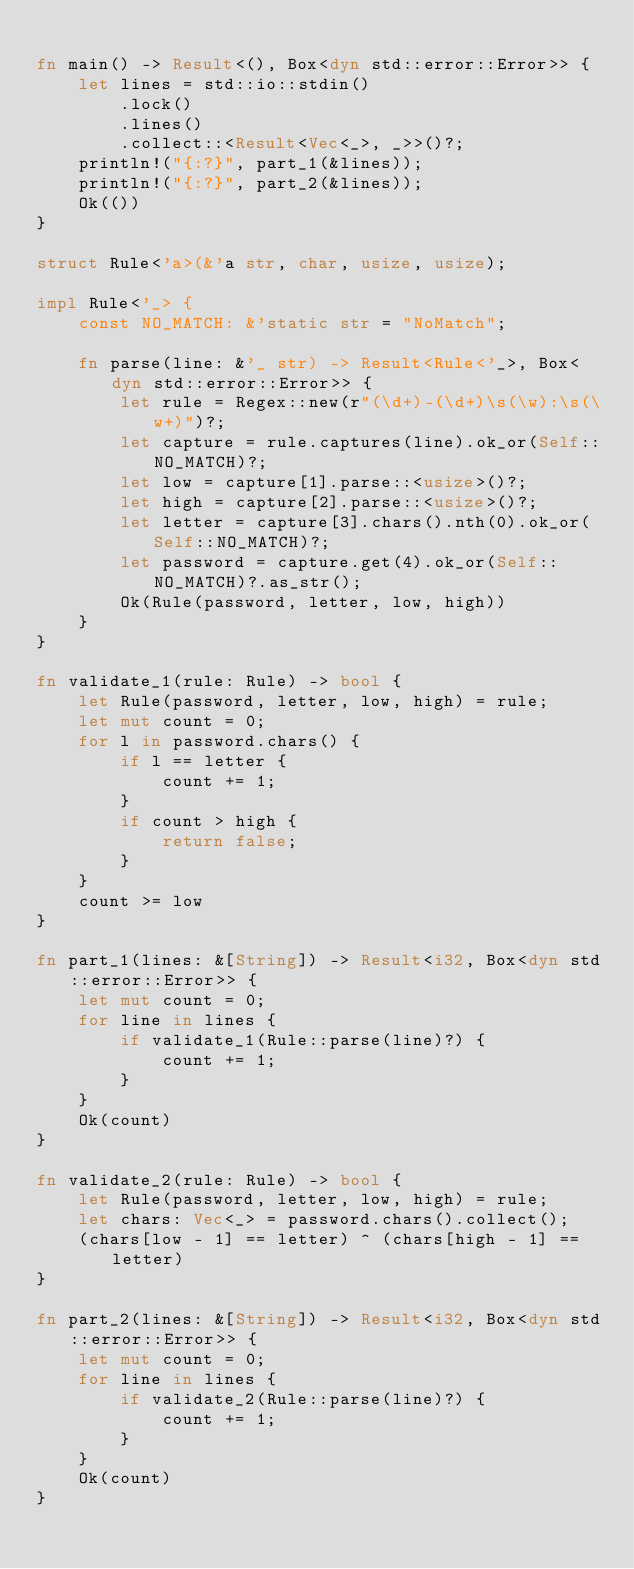Convert code to text. <code><loc_0><loc_0><loc_500><loc_500><_Rust_>
fn main() -> Result<(), Box<dyn std::error::Error>> {
    let lines = std::io::stdin()
        .lock()
        .lines()
        .collect::<Result<Vec<_>, _>>()?;
    println!("{:?}", part_1(&lines));
    println!("{:?}", part_2(&lines));
    Ok(())
}

struct Rule<'a>(&'a str, char, usize, usize);

impl Rule<'_> {
    const NO_MATCH: &'static str = "NoMatch";

    fn parse(line: &'_ str) -> Result<Rule<'_>, Box<dyn std::error::Error>> {
        let rule = Regex::new(r"(\d+)-(\d+)\s(\w):\s(\w+)")?;
        let capture = rule.captures(line).ok_or(Self::NO_MATCH)?;
        let low = capture[1].parse::<usize>()?;
        let high = capture[2].parse::<usize>()?;
        let letter = capture[3].chars().nth(0).ok_or(Self::NO_MATCH)?;
        let password = capture.get(4).ok_or(Self::NO_MATCH)?.as_str();
        Ok(Rule(password, letter, low, high))
    }
}

fn validate_1(rule: Rule) -> bool {
    let Rule(password, letter, low, high) = rule;
    let mut count = 0;
    for l in password.chars() {
        if l == letter {
            count += 1;
        }
        if count > high {
            return false;
        }
    }
    count >= low
}

fn part_1(lines: &[String]) -> Result<i32, Box<dyn std::error::Error>> {
    let mut count = 0;
    for line in lines {
        if validate_1(Rule::parse(line)?) {
            count += 1;
        }
    }
    Ok(count)
}

fn validate_2(rule: Rule) -> bool {
    let Rule(password, letter, low, high) = rule;
    let chars: Vec<_> = password.chars().collect();
    (chars[low - 1] == letter) ^ (chars[high - 1] == letter)
}

fn part_2(lines: &[String]) -> Result<i32, Box<dyn std::error::Error>> {
    let mut count = 0;
    for line in lines {
        if validate_2(Rule::parse(line)?) {
            count += 1;
        }
    }
    Ok(count)
}
</code> 